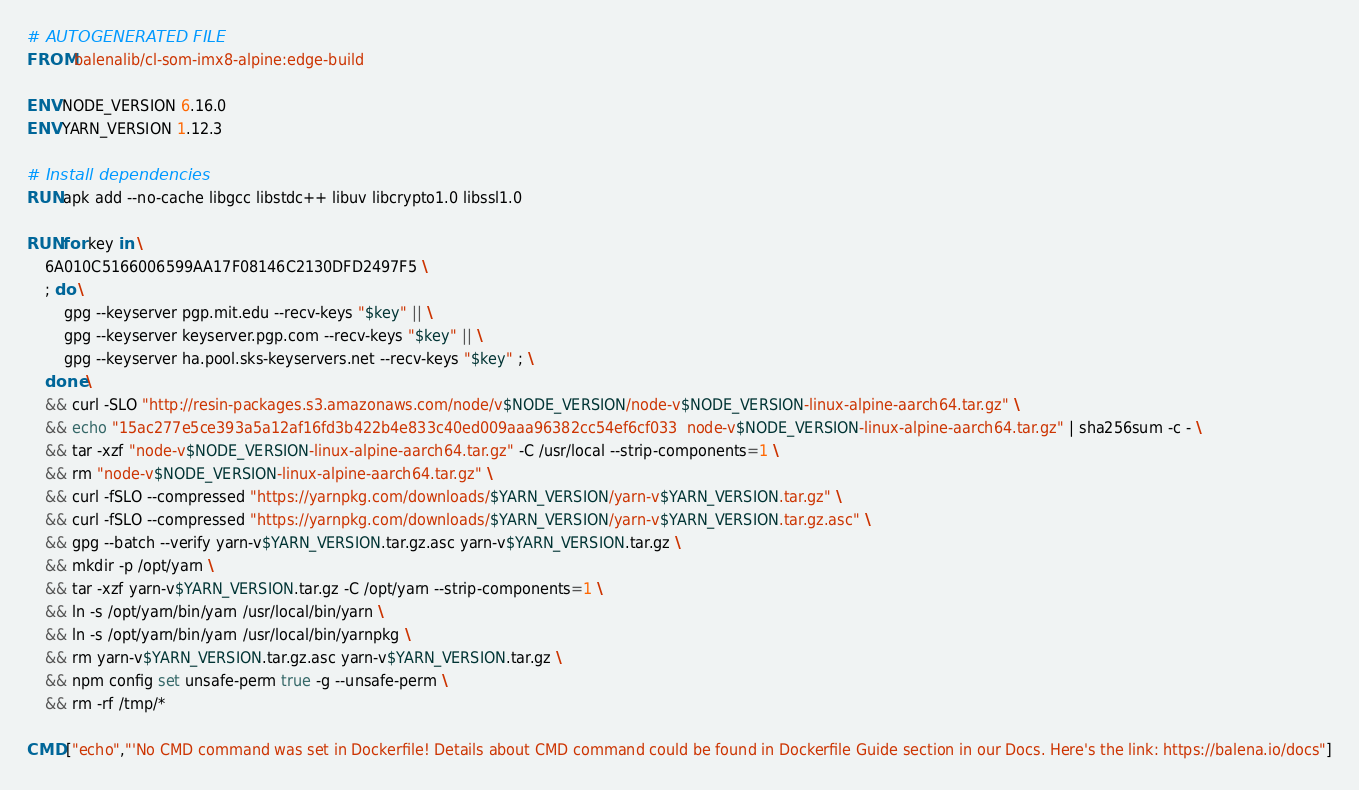<code> <loc_0><loc_0><loc_500><loc_500><_Dockerfile_># AUTOGENERATED FILE
FROM balenalib/cl-som-imx8-alpine:edge-build

ENV NODE_VERSION 6.16.0
ENV YARN_VERSION 1.12.3

# Install dependencies
RUN apk add --no-cache libgcc libstdc++ libuv libcrypto1.0 libssl1.0

RUN for key in \
	6A010C5166006599AA17F08146C2130DFD2497F5 \
	; do \
		gpg --keyserver pgp.mit.edu --recv-keys "$key" || \
		gpg --keyserver keyserver.pgp.com --recv-keys "$key" || \
		gpg --keyserver ha.pool.sks-keyservers.net --recv-keys "$key" ; \
	done \
	&& curl -SLO "http://resin-packages.s3.amazonaws.com/node/v$NODE_VERSION/node-v$NODE_VERSION-linux-alpine-aarch64.tar.gz" \
	&& echo "15ac277e5ce393a5a12af16fd3b422b4e833c40ed009aaa96382cc54ef6cf033  node-v$NODE_VERSION-linux-alpine-aarch64.tar.gz" | sha256sum -c - \
	&& tar -xzf "node-v$NODE_VERSION-linux-alpine-aarch64.tar.gz" -C /usr/local --strip-components=1 \
	&& rm "node-v$NODE_VERSION-linux-alpine-aarch64.tar.gz" \
	&& curl -fSLO --compressed "https://yarnpkg.com/downloads/$YARN_VERSION/yarn-v$YARN_VERSION.tar.gz" \
	&& curl -fSLO --compressed "https://yarnpkg.com/downloads/$YARN_VERSION/yarn-v$YARN_VERSION.tar.gz.asc" \
	&& gpg --batch --verify yarn-v$YARN_VERSION.tar.gz.asc yarn-v$YARN_VERSION.tar.gz \
	&& mkdir -p /opt/yarn \
	&& tar -xzf yarn-v$YARN_VERSION.tar.gz -C /opt/yarn --strip-components=1 \
	&& ln -s /opt/yarn/bin/yarn /usr/local/bin/yarn \
	&& ln -s /opt/yarn/bin/yarn /usr/local/bin/yarnpkg \
	&& rm yarn-v$YARN_VERSION.tar.gz.asc yarn-v$YARN_VERSION.tar.gz \
	&& npm config set unsafe-perm true -g --unsafe-perm \
	&& rm -rf /tmp/*

CMD ["echo","'No CMD command was set in Dockerfile! Details about CMD command could be found in Dockerfile Guide section in our Docs. Here's the link: https://balena.io/docs"]</code> 